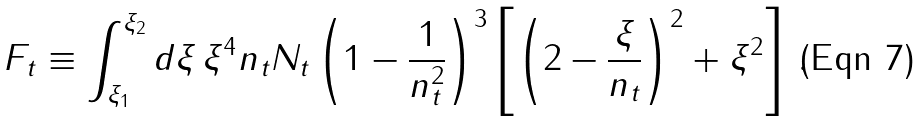Convert formula to latex. <formula><loc_0><loc_0><loc_500><loc_500>F _ { t } \equiv \int _ { \xi _ { 1 } } ^ { \xi _ { 2 } } d \xi \, \xi ^ { 4 } n _ { t } N _ { t } \left ( 1 - \frac { 1 } { n _ { t } ^ { 2 } } \right ) ^ { 3 } \left [ \left ( 2 - \frac { \xi } { n _ { t } } \right ) ^ { 2 } + \xi ^ { 2 } \right ] \, .</formula> 